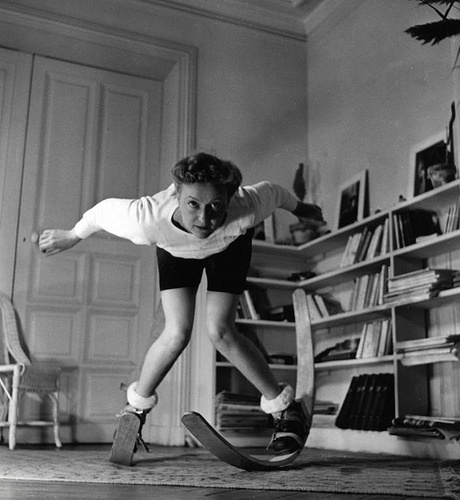Describe the objects in this image and their specific colors. I can see people in black, darkgray, gray, and lightgray tones, book in black, gray, darkgray, and lightgray tones, chair in black, gray, darkgray, and lightgray tones, skis in black, gray, darkgray, and lightgray tones, and book in black, darkgray, and gray tones in this image. 